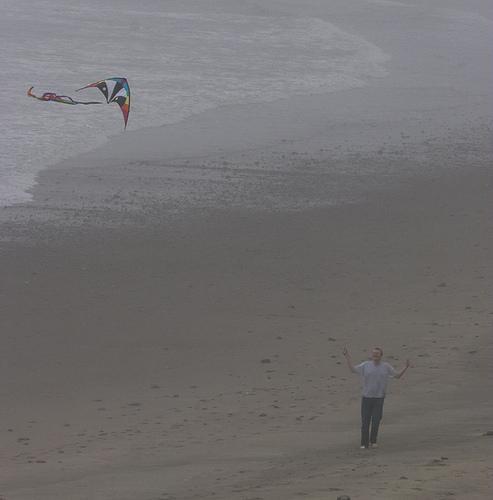How many people on the beach?
Give a very brief answer. 1. How many elephants are visible?
Give a very brief answer. 0. 